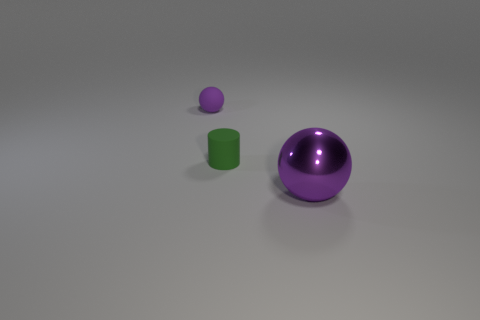There is another sphere that is the same color as the tiny ball; what size is it?
Keep it short and to the point. Large. How many other objects are the same size as the metallic sphere?
Offer a very short reply. 0. How many objects are both to the right of the green cylinder and behind the big thing?
Make the answer very short. 0. There is a purple ball in front of the green cylinder; does it have the same size as the purple thing on the left side of the tiny green rubber thing?
Your answer should be very brief. No. There is a purple thing on the left side of the tiny green matte thing; what is its size?
Your answer should be very brief. Small. What number of objects are purple things that are behind the green thing or things that are on the right side of the purple matte object?
Make the answer very short. 3. Is there anything else that is the same color as the cylinder?
Your answer should be compact. No. Are there the same number of cylinders in front of the green cylinder and green rubber cylinders right of the big metallic thing?
Ensure brevity in your answer.  Yes. Is the number of small things that are to the left of the purple matte object greater than the number of small green things?
Keep it short and to the point. No. What number of things are balls that are behind the shiny object or small balls?
Your answer should be compact. 1. 